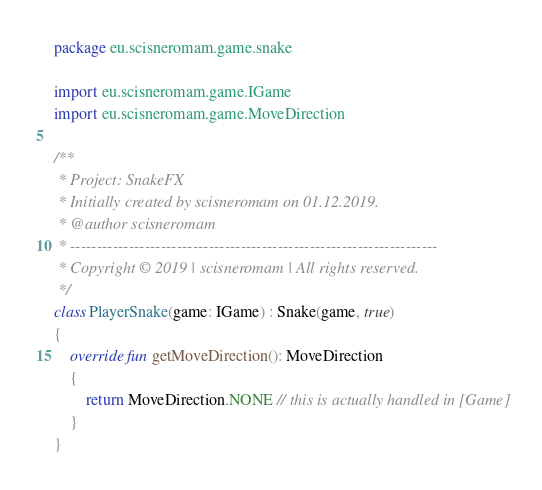<code> <loc_0><loc_0><loc_500><loc_500><_Kotlin_>package eu.scisneromam.game.snake

import eu.scisneromam.game.IGame
import eu.scisneromam.game.MoveDirection

/**
 * Project: SnakeFX
 * Initially created by scisneromam on 01.12.2019.
 * @author scisneromam
 * ---------------------------------------------------------------------
 * Copyright © 2019 | scisneromam | All rights reserved.
 */
class PlayerSnake(game: IGame) : Snake(game, true)
{
    override fun getMoveDirection(): MoveDirection
    {
        return MoveDirection.NONE // this is actually handled in [Game]
    }
}</code> 